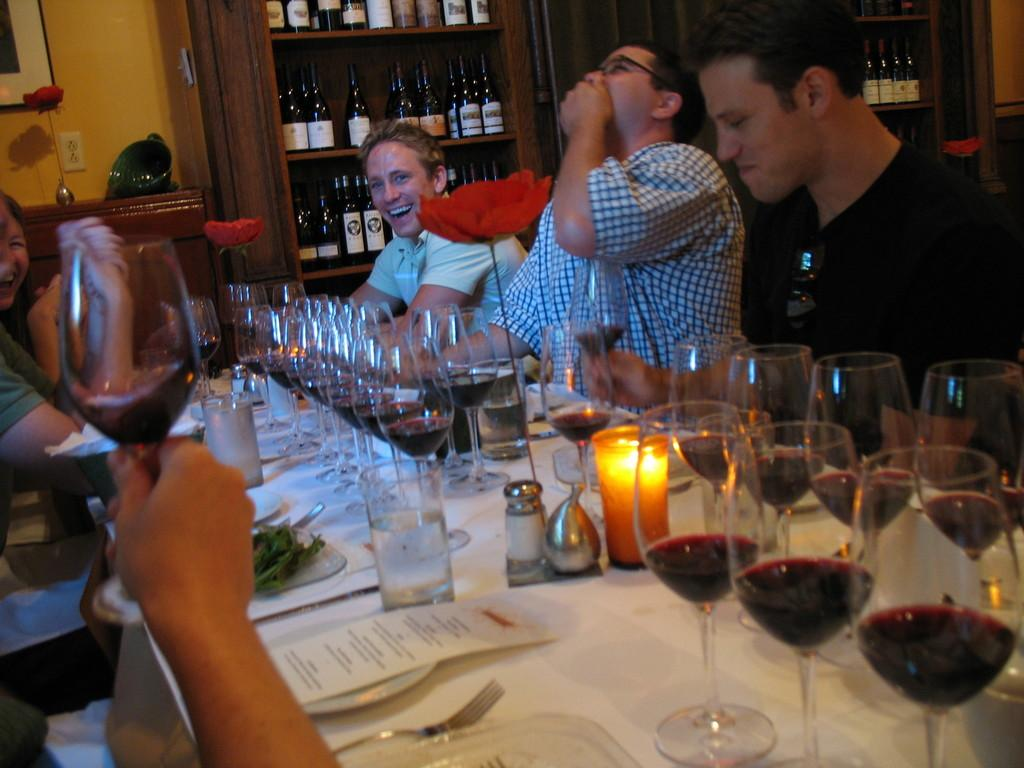What is the general mood or expression of the people in the image? The people in the image are smiling, which suggests a positive or happy mood. What type of beverage is in the glasses in the image? The glasses in the image are filled with wine. What piece of furniture is present in the image? There is a table in the image. What type of object is present on the table in the image? There is a paper on the table in the image. What utensil can be seen in the image? There is a fork in the image. What type of plant container is present in the image? There is a flower pot in the image. What can be seen in the background of the image? There is a wooden rack filled with bottles in the background of the image. Can you tell me how many animals are in the zoo in the image? There is no zoo present in the image, so it is not possible to determine the number of animals. What type of oil is being used to paint the picture in the image? There is no picture or painting in the image, so it is not possible to determine the type of oil being used. 